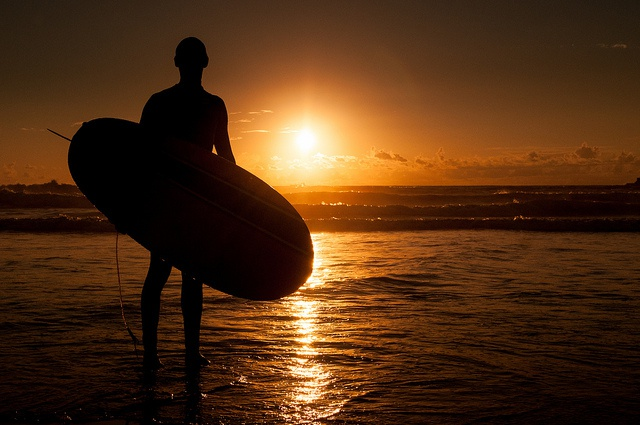Describe the objects in this image and their specific colors. I can see surfboard in black, maroon, and brown tones and people in black, maroon, and brown tones in this image. 